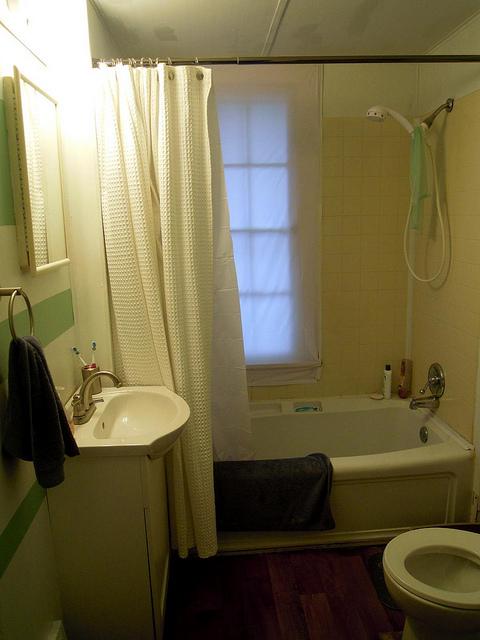Is the toilet lid down?
Quick response, please. No. Are both towels the same color?
Be succinct. Yes. Is the shower curtain open?
Write a very short answer. Yes. Is there a tissue box installed at the wall?
Give a very brief answer. No. How many curtains are there?
Short answer required. 2. Is there only one shower curtain or two?
Write a very short answer. 1. 